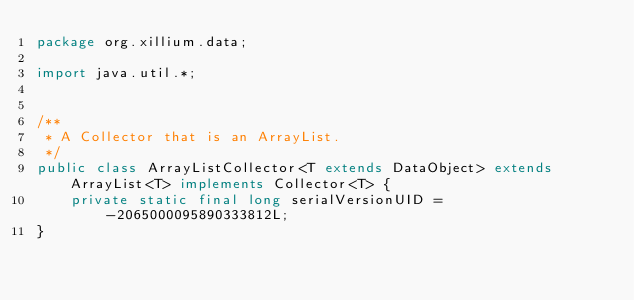<code> <loc_0><loc_0><loc_500><loc_500><_Java_>package org.xillium.data;

import java.util.*;


/**
 * A Collector that is an ArrayList.
 */
public class ArrayListCollector<T extends DataObject> extends ArrayList<T> implements Collector<T> {
    private static final long serialVersionUID = -2065000095890333812L;
}
</code> 